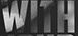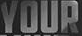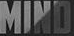What text is displayed in these images sequentially, separated by a semicolon? WITH; YOUR; MIND 